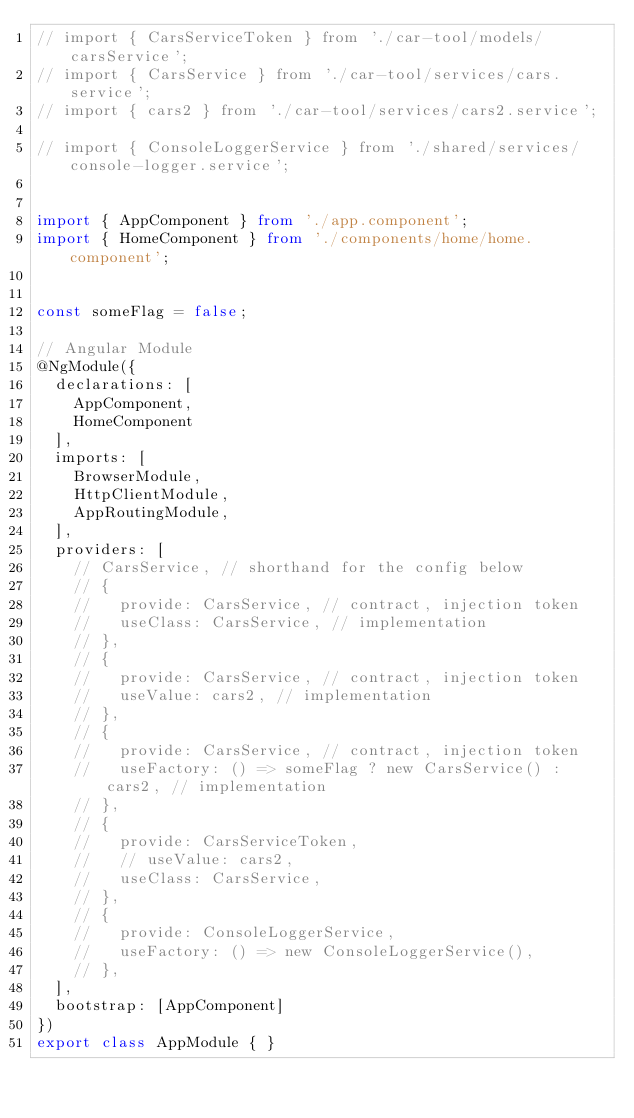<code> <loc_0><loc_0><loc_500><loc_500><_TypeScript_>// import { CarsServiceToken } from './car-tool/models/carsService';
// import { CarsService } from './car-tool/services/cars.service';
// import { cars2 } from './car-tool/services/cars2.service';

// import { ConsoleLoggerService } from './shared/services/console-logger.service';


import { AppComponent } from './app.component';
import { HomeComponent } from './components/home/home.component';


const someFlag = false;

// Angular Module
@NgModule({
  declarations: [
    AppComponent,
    HomeComponent
  ],
  imports: [
    BrowserModule,
    HttpClientModule,
    AppRoutingModule,
  ],
  providers: [
    // CarsService, // shorthand for the config below
    // {
    //   provide: CarsService, // contract, injection token
    //   useClass: CarsService, // implementation
    // },
    // {
    //   provide: CarsService, // contract, injection token
    //   useValue: cars2, // implementation
    // },
    // {
    //   provide: CarsService, // contract, injection token
    //   useFactory: () => someFlag ? new CarsService() : cars2, // implementation
    // },
    // {
    //   provide: CarsServiceToken,
    //   // useValue: cars2,
    //   useClass: CarsService,
    // },
    // {
    //   provide: ConsoleLoggerService,
    //   useFactory: () => new ConsoleLoggerService(),
    // },
  ],
  bootstrap: [AppComponent]
})
export class AppModule { }
</code> 